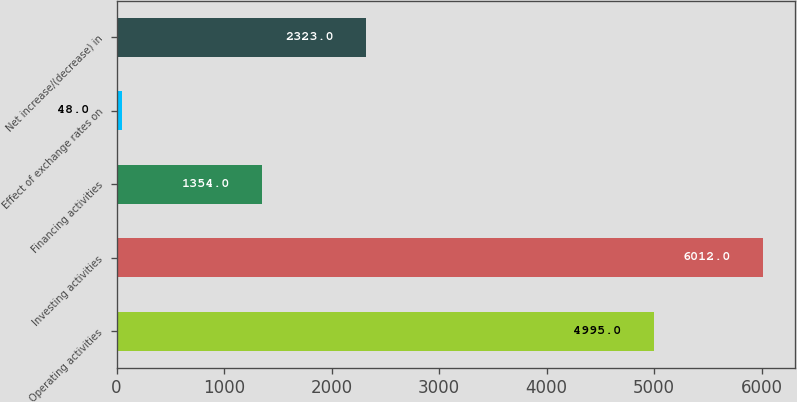Convert chart to OTSL. <chart><loc_0><loc_0><loc_500><loc_500><bar_chart><fcel>Operating activities<fcel>Investing activities<fcel>Financing activities<fcel>Effect of exchange rates on<fcel>Net increase/(decrease) in<nl><fcel>4995<fcel>6012<fcel>1354<fcel>48<fcel>2323<nl></chart> 